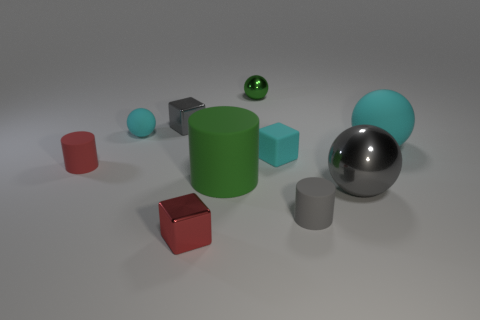Subtract all cubes. How many objects are left? 7 Subtract all tiny cyan rubber cylinders. Subtract all gray metal balls. How many objects are left? 9 Add 2 cylinders. How many cylinders are left? 5 Add 1 green matte cylinders. How many green matte cylinders exist? 2 Subtract 1 cyan cubes. How many objects are left? 9 